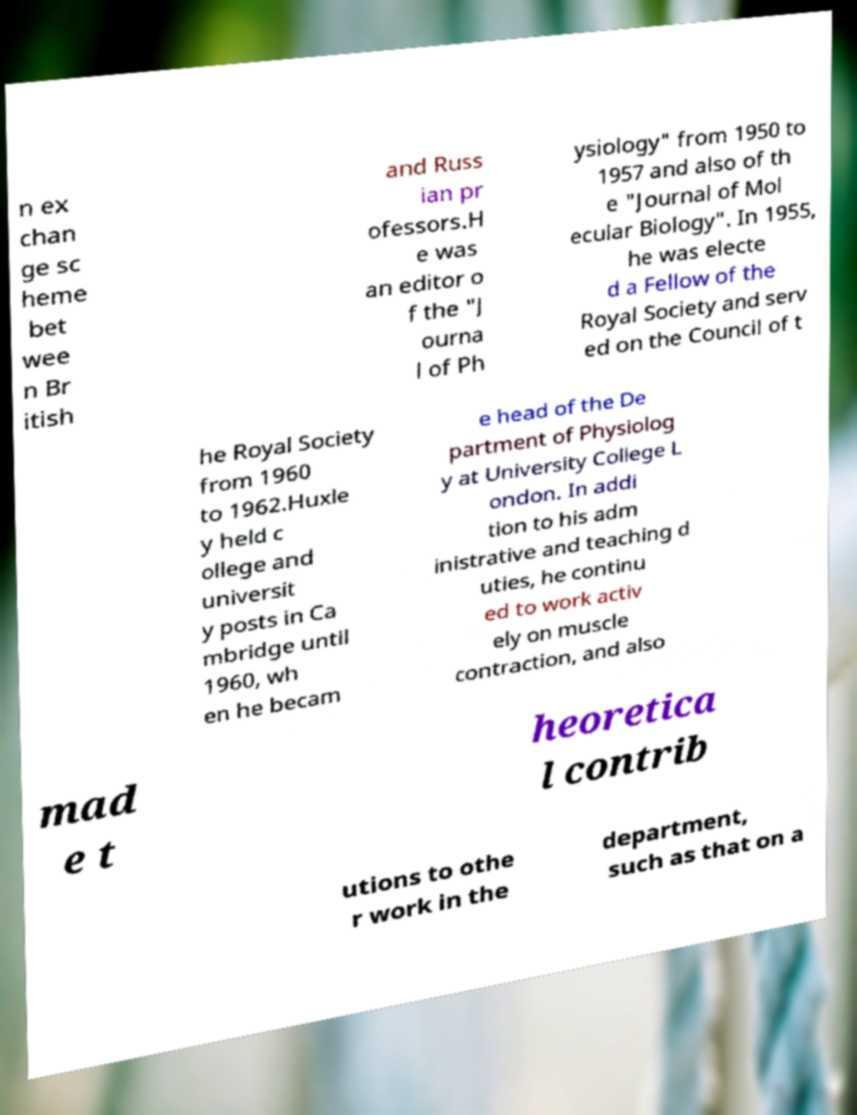Please read and relay the text visible in this image. What does it say? n ex chan ge sc heme bet wee n Br itish and Russ ian pr ofessors.H e was an editor o f the "J ourna l of Ph ysiology" from 1950 to 1957 and also of th e "Journal of Mol ecular Biology". In 1955, he was electe d a Fellow of the Royal Society and serv ed on the Council of t he Royal Society from 1960 to 1962.Huxle y held c ollege and universit y posts in Ca mbridge until 1960, wh en he becam e head of the De partment of Physiolog y at University College L ondon. In addi tion to his adm inistrative and teaching d uties, he continu ed to work activ ely on muscle contraction, and also mad e t heoretica l contrib utions to othe r work in the department, such as that on a 